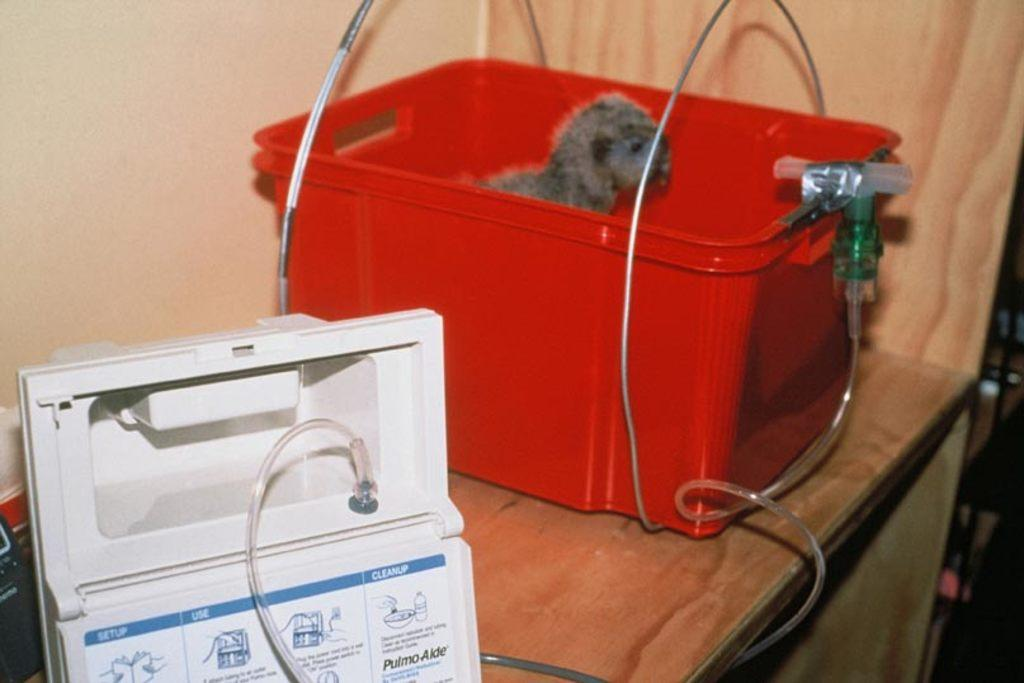What piece of furniture is present in the image? There is a table in the image. What is on the table? There is a red plastic container on the table, as well as other unspecified items. What can be seen in the background of the image? There is a wall in the background of the image. Can you see a kitten using its finger to drink liquid from the red plastic container in the image? No, there is no kitten or liquid present in the image. 